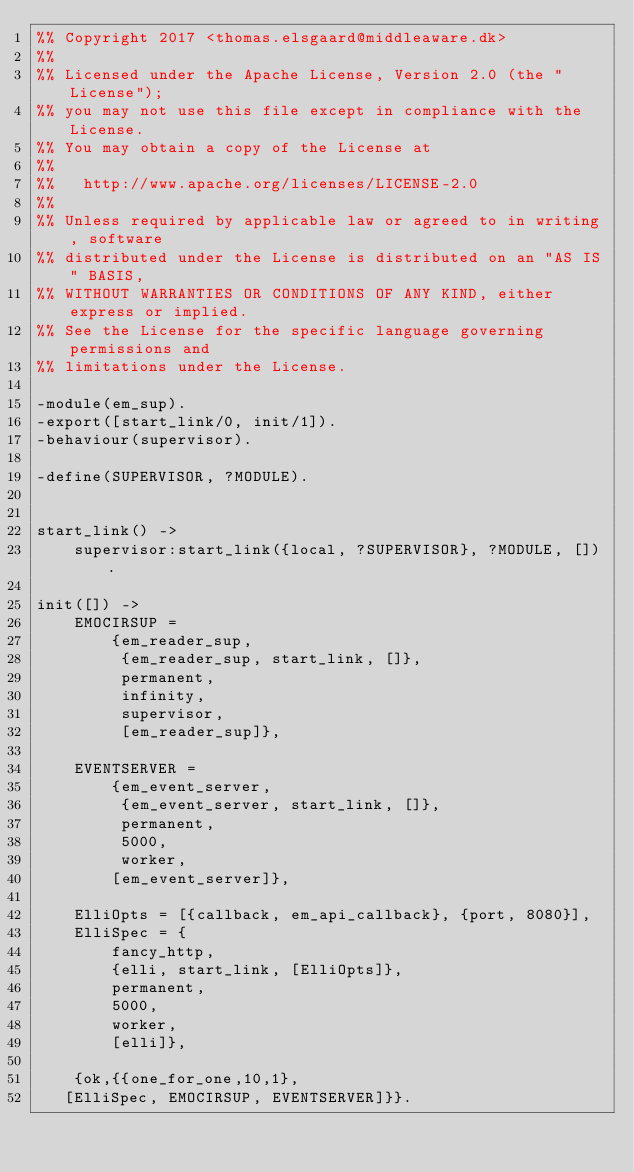Convert code to text. <code><loc_0><loc_0><loc_500><loc_500><_Erlang_>%% Copyright 2017 <thomas.elsgaard@middleaware.dk>
%%
%% Licensed under the Apache License, Version 2.0 (the "License");
%% you may not use this file except in compliance with the License.
%% You may obtain a copy of the License at
%%
%%   http://www.apache.org/licenses/LICENSE-2.0
%%
%% Unless required by applicable law or agreed to in writing, software
%% distributed under the License is distributed on an "AS IS" BASIS,
%% WITHOUT WARRANTIES OR CONDITIONS OF ANY KIND, either express or implied.
%% See the License for the specific language governing permissions and
%% limitations under the License.

-module(em_sup).
-export([start_link/0, init/1]).
-behaviour(supervisor).

-define(SUPERVISOR, ?MODULE).

 
start_link() ->
    supervisor:start_link({local, ?SUPERVISOR}, ?MODULE, []).
 
init([]) ->
    EMOCIRSUP =
        {em_reader_sup,
         {em_reader_sup, start_link, []},
         permanent,
         infinity,
         supervisor,
         [em_reader_sup]},

    EVENTSERVER =
        {em_event_server,
         {em_event_server, start_link, []},
         permanent,
         5000,
         worker,
        [em_event_server]},
   
    ElliOpts = [{callback, em_api_callback}, {port, 8080}],
    ElliSpec = {
        fancy_http,
        {elli, start_link, [ElliOpts]},
        permanent,
        5000,
        worker,
        [elli]},
    
    {ok,{{one_for_one,10,1},
	 [ElliSpec, EMOCIRSUP, EVENTSERVER]}}.    
</code> 